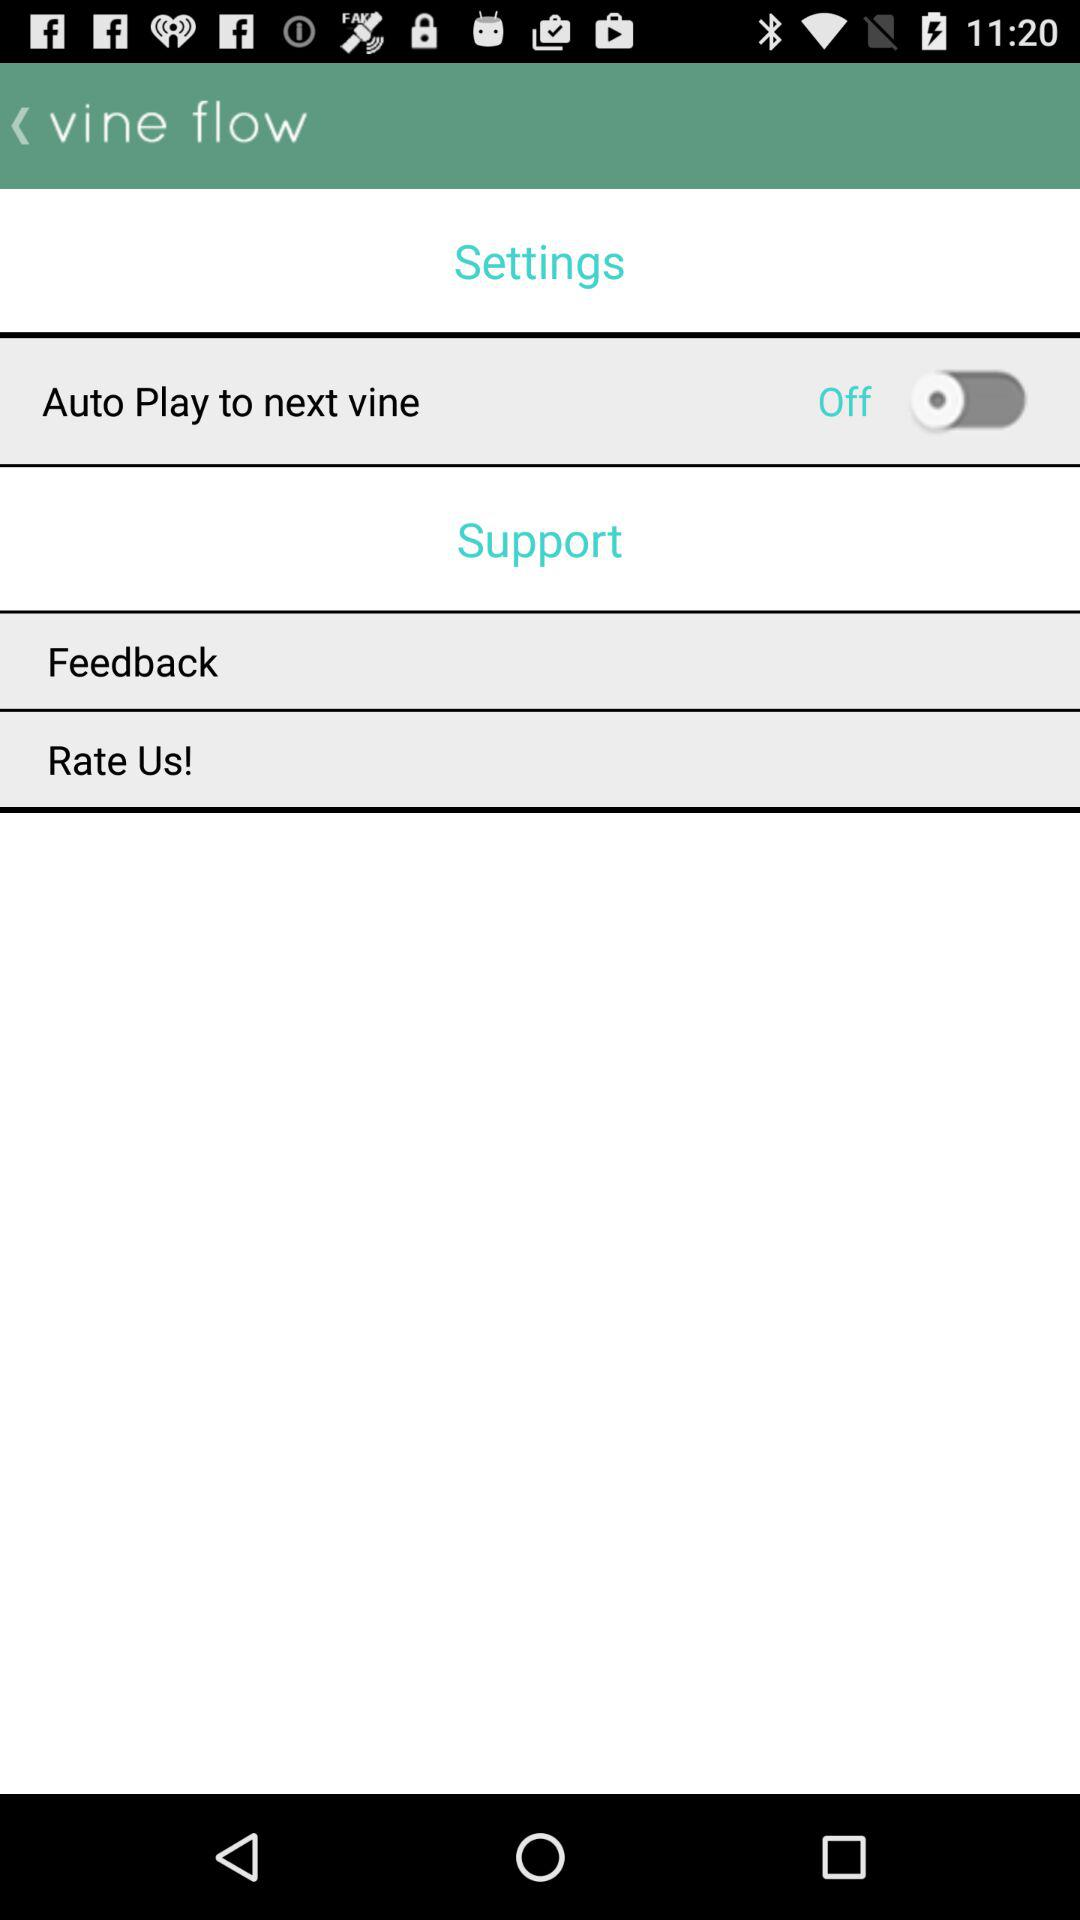What's the status of "Auto Play to next vine"? The status is "Off". 